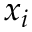<formula> <loc_0><loc_0><loc_500><loc_500>x _ { i }</formula> 